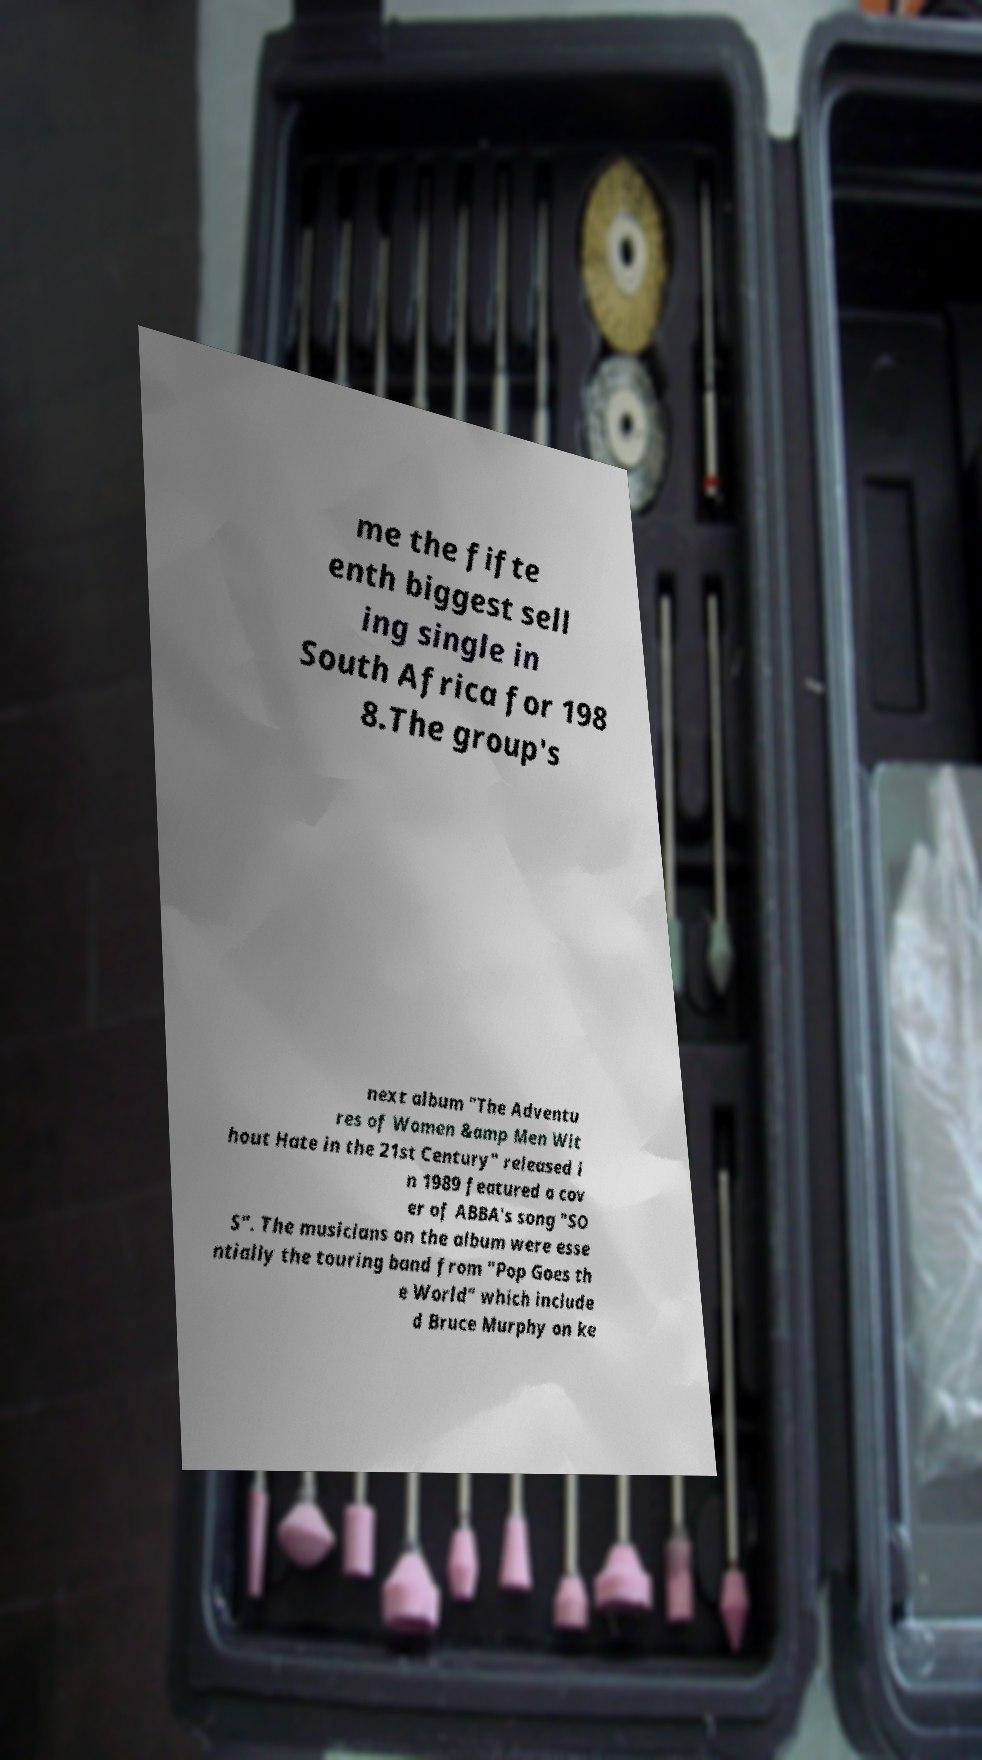Can you accurately transcribe the text from the provided image for me? me the fifte enth biggest sell ing single in South Africa for 198 8.The group's next album "The Adventu res of Women &amp Men Wit hout Hate in the 21st Century" released i n 1989 featured a cov er of ABBA's song "SO S". The musicians on the album were esse ntially the touring band from "Pop Goes th e World" which include d Bruce Murphy on ke 